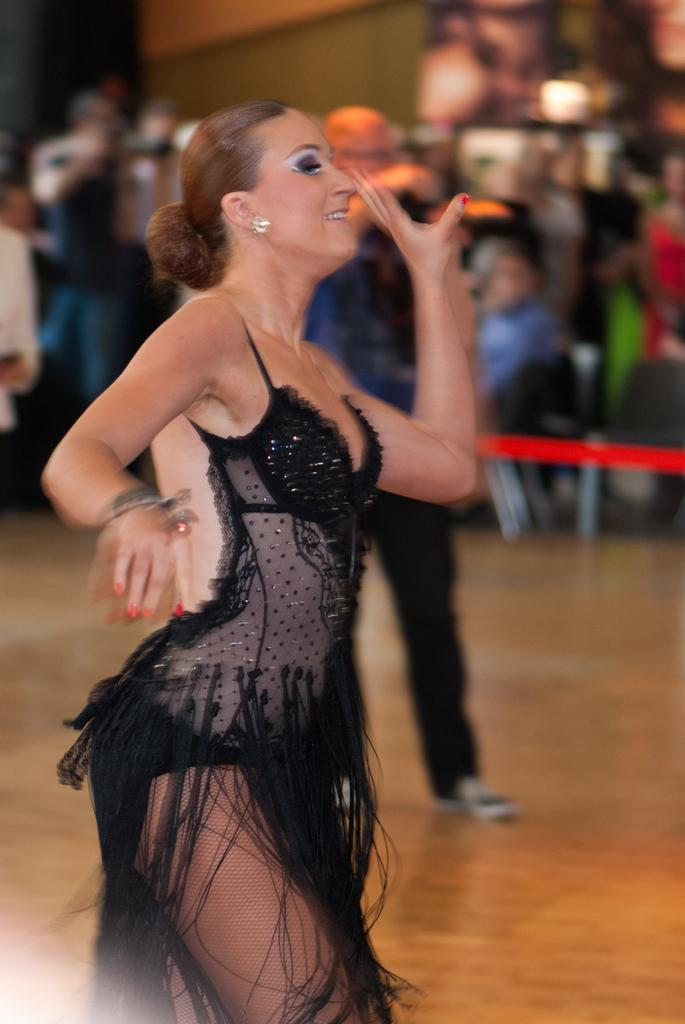What is the main subject of the image? The main subject of the image is a group of people. Can you describe the setting of the image? There is a wall in the image, which suggests a specific location or background. Who is the most prominent person in the group? A woman is standing in the front of the group. What is the woman wearing? The woman is wearing a black color dress. What type of rhythm can be heard coming from the clocks in the image? There are no clocks present in the image, so it's not possible to determine what type of rhythm might be heard. 